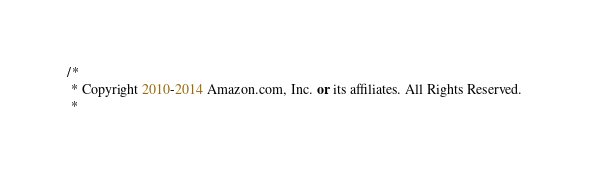Convert code to text. <code><loc_0><loc_0><loc_500><loc_500><_C#_>/*
 * Copyright 2010-2014 Amazon.com, Inc. or its affiliates. All Rights Reserved.
 * </code> 